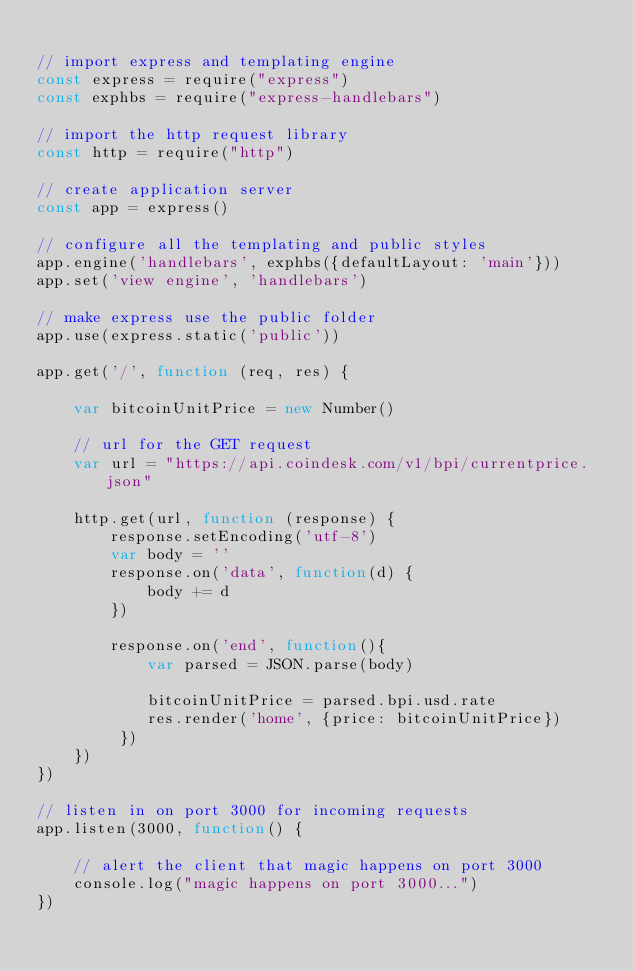Convert code to text. <code><loc_0><loc_0><loc_500><loc_500><_JavaScript_>
// import express and templating engine
const express = require("express")
const exphbs = require("express-handlebars")

// import the http request library
const http = require("http")

// create application server
const app = express()

// configure all the templating and public styles
app.engine('handlebars', exphbs({defaultLayout: 'main'}))
app.set('view engine', 'handlebars')

// make express use the public folder 
app.use(express.static('public'))

app.get('/', function (req, res) {

	var bitcoinUnitPrice = new Number()

	// url for the GET request
	var url = "https://api.coindesk.com/v1/bpi/currentprice.json"

	http.get(url, function (response) {
		response.setEncoding('utf-8')
        var body = ''
        response.on('data', function(d) {
            body += d
        })

        response.on('end', function(){
            var parsed = JSON.parse(body)

            bitcoinUnitPrice = parsed.bpi.usd.rate
            res.render('home', {price: bitcoinUnitPrice})
         })
	})
})

// listen in on port 3000 for incoming requests
app.listen(3000, function() {

    // alert the client that magic happens on port 3000
    console.log("magic happens on port 3000...")
})

</code> 